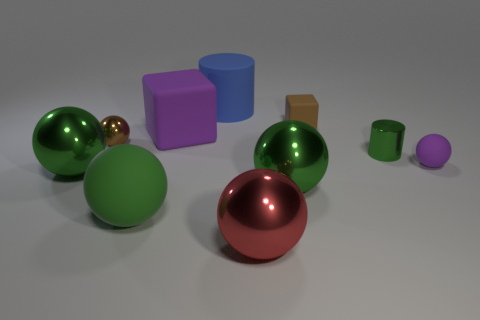How many green spheres must be subtracted to get 1 green spheres? 2 Subtract all yellow cubes. How many green balls are left? 3 Subtract 4 spheres. How many spheres are left? 2 Subtract all purple balls. How many balls are left? 5 Subtract all brown balls. How many balls are left? 5 Subtract all gray balls. Subtract all purple cylinders. How many balls are left? 6 Subtract all blocks. How many objects are left? 8 Add 5 brown balls. How many brown balls exist? 6 Subtract 0 cyan cubes. How many objects are left? 10 Subtract all big balls. Subtract all matte things. How many objects are left? 1 